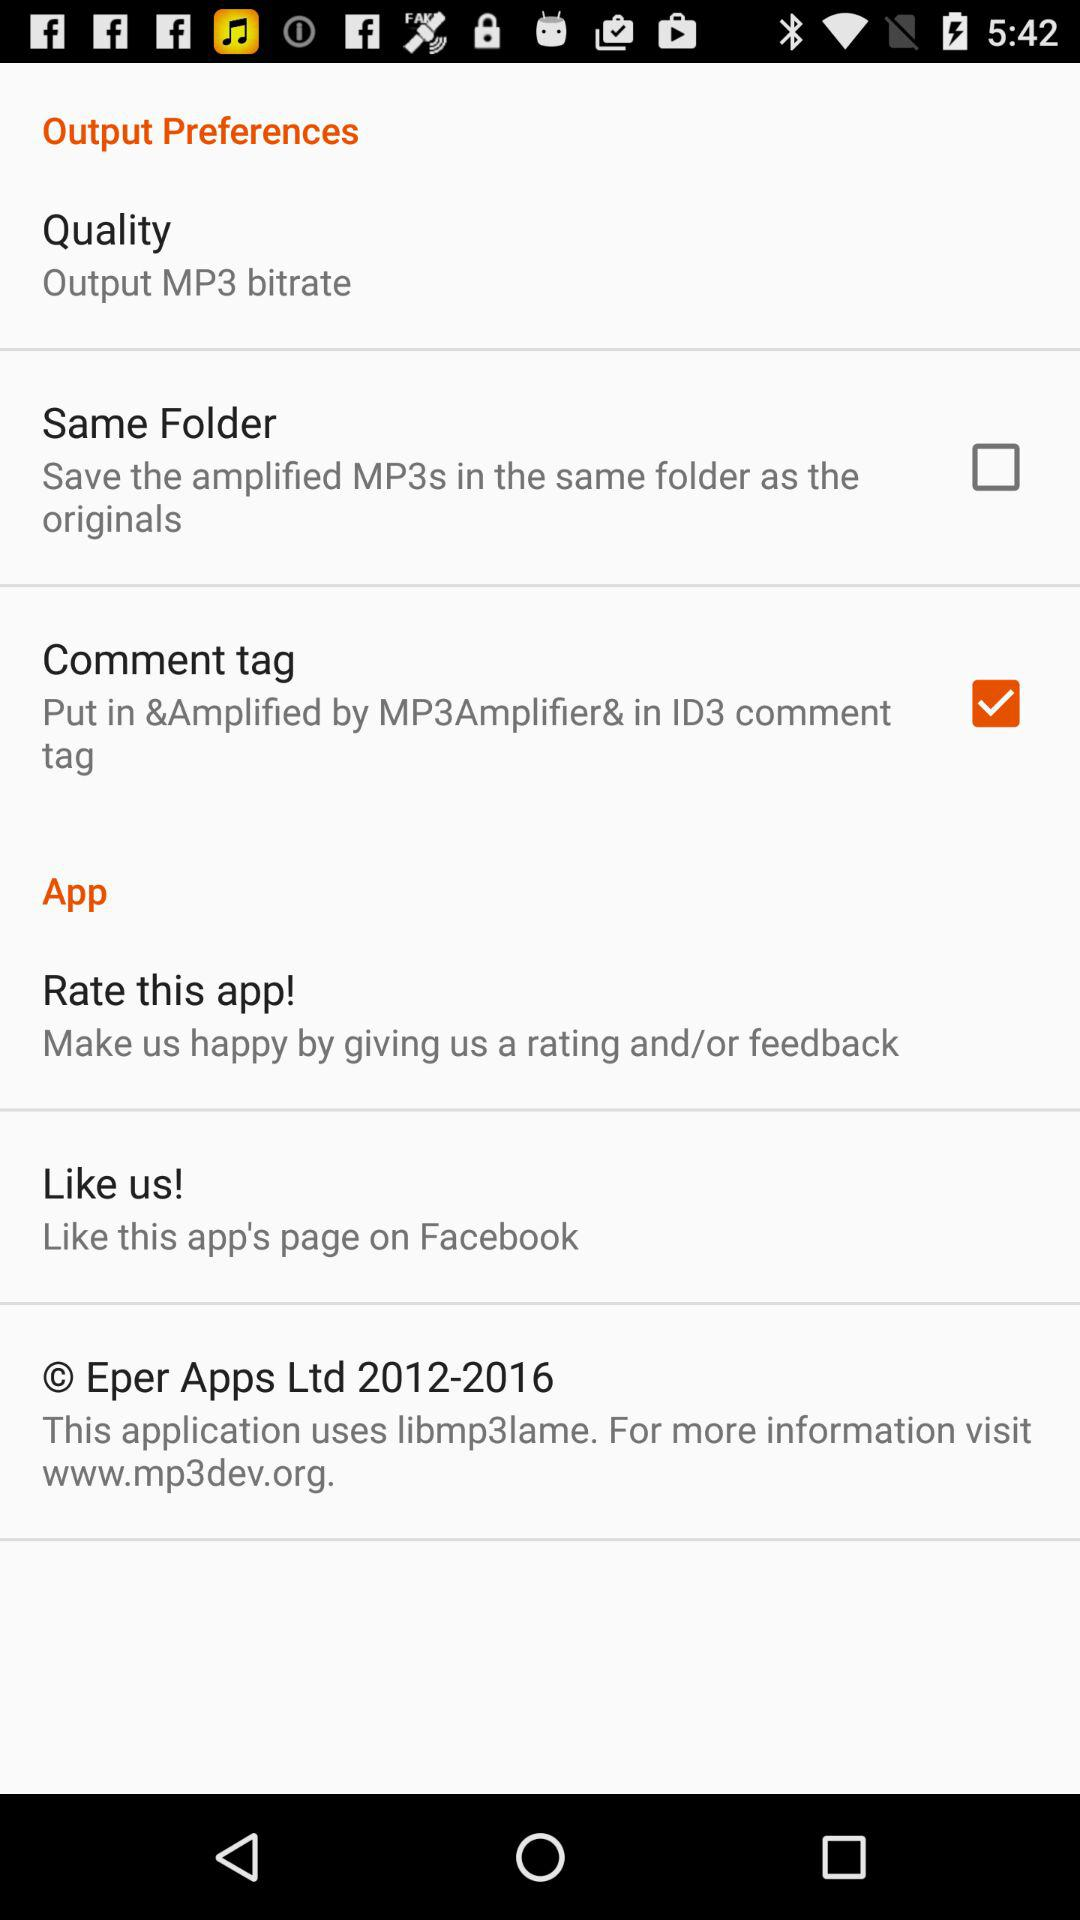What is the status of "Same folder"? The status is "off". 